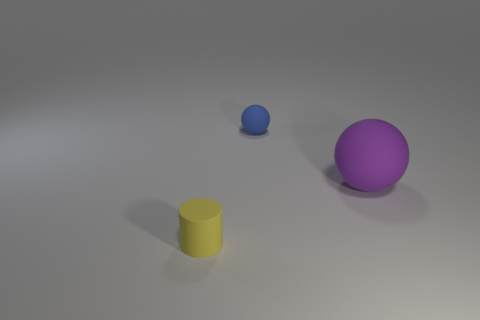Are there any balls that have the same material as the tiny yellow thing?
Offer a very short reply. Yes. Is the shape of the small matte object behind the purple rubber ball the same as the small thing that is in front of the big purple matte object?
Keep it short and to the point. No. Are any things visible?
Your answer should be compact. Yes. There is a cylinder that is the same size as the blue matte thing; what color is it?
Your answer should be compact. Yellow. What number of other yellow things are the same shape as the tiny yellow matte object?
Your answer should be very brief. 0. Is the blue ball to the left of the purple rubber object made of the same material as the big purple object?
Your answer should be compact. Yes. What number of spheres are small yellow rubber objects or big purple matte objects?
Offer a terse response. 1. What shape is the thing in front of the ball in front of the matte ball behind the big sphere?
Your response must be concise. Cylinder. What number of other objects have the same size as the yellow thing?
Offer a very short reply. 1. Are there any large purple rubber balls that are right of the tiny matte object that is behind the small rubber cylinder?
Give a very brief answer. Yes. 